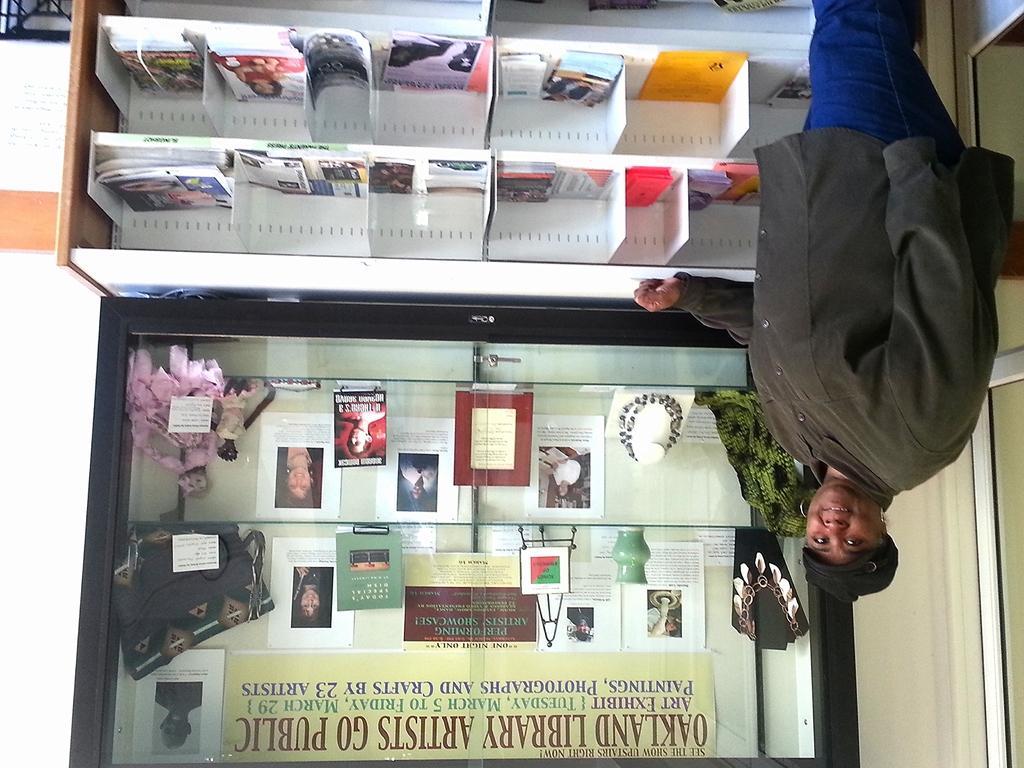How would you summarize this image in a sentence or two? A person is standing. This person wore jacket and cap. In these racks there are books and papers. In this glass cupboard we can see jewelry, toy, bag, books, papers and things. This is banner. 